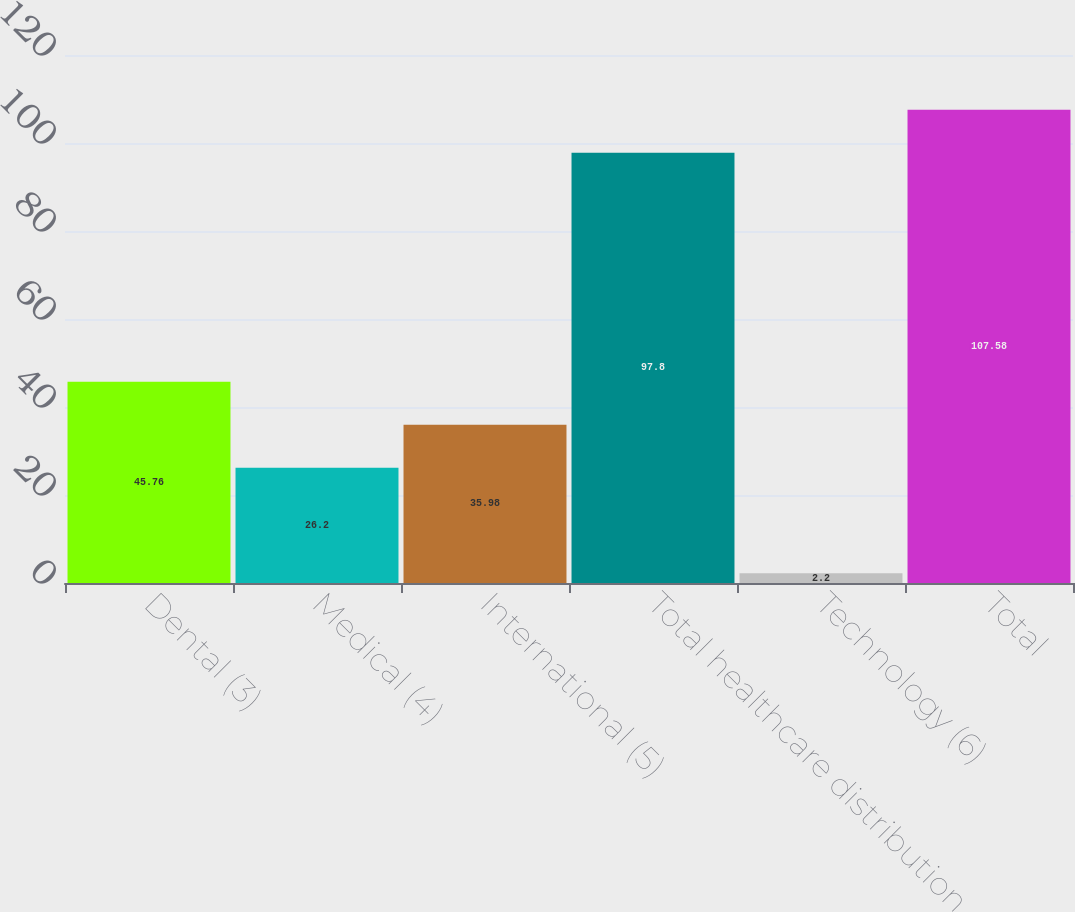Convert chart. <chart><loc_0><loc_0><loc_500><loc_500><bar_chart><fcel>Dental (3)<fcel>Medical (4)<fcel>International (5)<fcel>Total healthcare distribution<fcel>Technology (6)<fcel>Total<nl><fcel>45.76<fcel>26.2<fcel>35.98<fcel>97.8<fcel>2.2<fcel>107.58<nl></chart> 